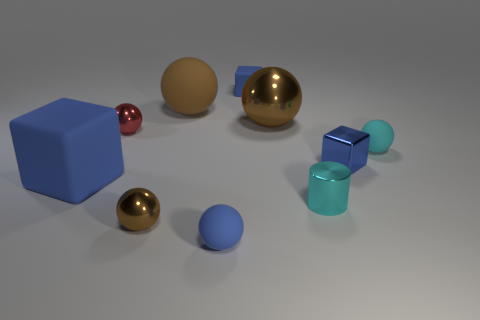What is the material of the block that is behind the matte object right of the small blue cube behind the red shiny ball?
Your answer should be compact. Rubber. What number of metallic objects are tiny blue things or cyan objects?
Ensure brevity in your answer.  2. Is there a large green block?
Provide a short and direct response. No. What is the color of the small thing in front of the brown metal thing that is in front of the cyan metallic cylinder?
Your answer should be compact. Blue. What number of other objects are the same color as the large matte block?
Offer a terse response. 3. How many things are small brown metal balls or small shiny things that are right of the small metal cylinder?
Ensure brevity in your answer.  2. What is the color of the tiny matte ball that is in front of the metallic cylinder?
Your response must be concise. Blue. What is the shape of the brown matte thing?
Offer a very short reply. Sphere. The big thing that is in front of the tiny metallic sphere on the left side of the small brown sphere is made of what material?
Your response must be concise. Rubber. What number of other things are made of the same material as the big blue block?
Your response must be concise. 4. 